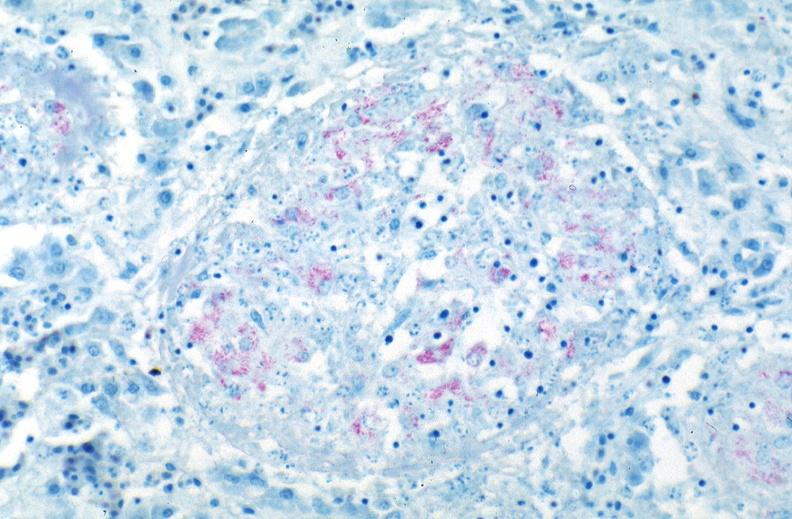what does this image show?
Answer the question using a single word or phrase. Lung 